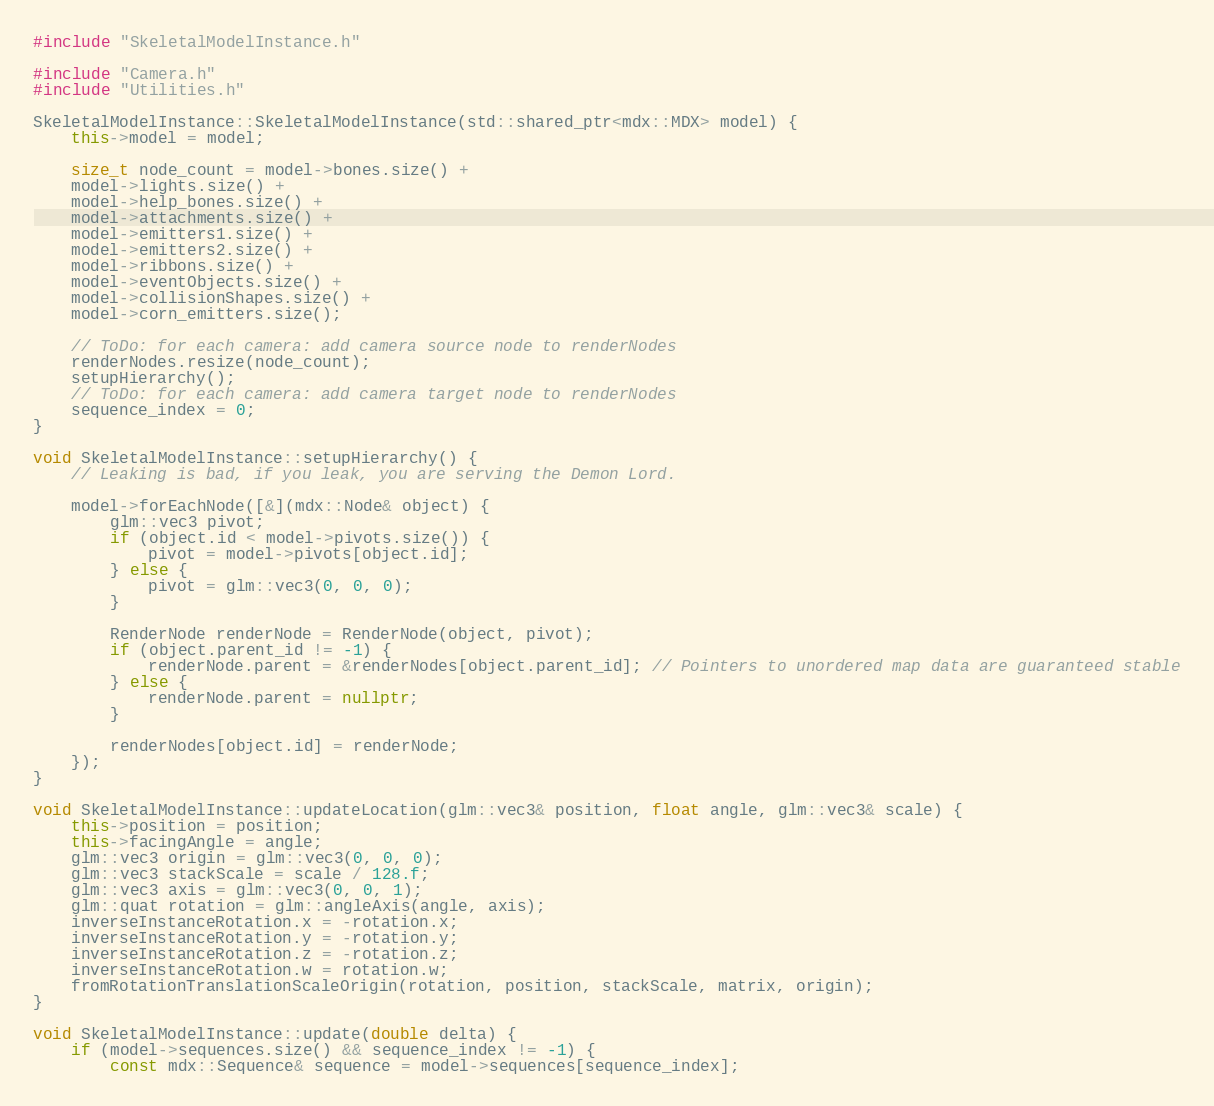Convert code to text. <code><loc_0><loc_0><loc_500><loc_500><_C++_>#include "SkeletalModelInstance.h"

#include "Camera.h"
#include "Utilities.h"

SkeletalModelInstance::SkeletalModelInstance(std::shared_ptr<mdx::MDX> model) {
	this->model = model;

	size_t node_count = model->bones.size() +
	model->lights.size() +
	model->help_bones.size() +
	model->attachments.size() +
	model->emitters1.size() +
	model->emitters2.size() +
	model->ribbons.size() +
	model->eventObjects.size() +
	model->collisionShapes.size() +
	model->corn_emitters.size();
	
	// ToDo: for each camera: add camera source node to renderNodes
	renderNodes.resize(node_count);
	setupHierarchy();
	// ToDo: for each camera: add camera target node to renderNodes
	sequence_index = 0;
}

void SkeletalModelInstance::setupHierarchy() {
	// Leaking is bad, if you leak, you are serving the Demon Lord.

	model->forEachNode([&](mdx::Node& object) {
		glm::vec3 pivot;
		if (object.id < model->pivots.size()) {
			pivot = model->pivots[object.id];
		} else {
			pivot = glm::vec3(0, 0, 0);
		}

		RenderNode renderNode = RenderNode(object, pivot);
		if (object.parent_id != -1) {
			renderNode.parent = &renderNodes[object.parent_id]; // Pointers to unordered map data are guaranteed stable
		} else {
			renderNode.parent = nullptr;
		}

		renderNodes[object.id] = renderNode;
	});
}

void SkeletalModelInstance::updateLocation(glm::vec3& position, float angle, glm::vec3& scale) {
	this->position = position;
	this->facingAngle = angle;
	glm::vec3 origin = glm::vec3(0, 0, 0);
	glm::vec3 stackScale = scale / 128.f;
	glm::vec3 axis = glm::vec3(0, 0, 1);
	glm::quat rotation = glm::angleAxis(angle, axis);
	inverseInstanceRotation.x = -rotation.x;
	inverseInstanceRotation.y = -rotation.y;
	inverseInstanceRotation.z = -rotation.z;
	inverseInstanceRotation.w = rotation.w;
	fromRotationTranslationScaleOrigin(rotation, position, stackScale, matrix, origin);
}

void SkeletalModelInstance::update(double delta) {
	if (model->sequences.size() && sequence_index != -1) {
		const mdx::Sequence& sequence = model->sequences[sequence_index];</code> 